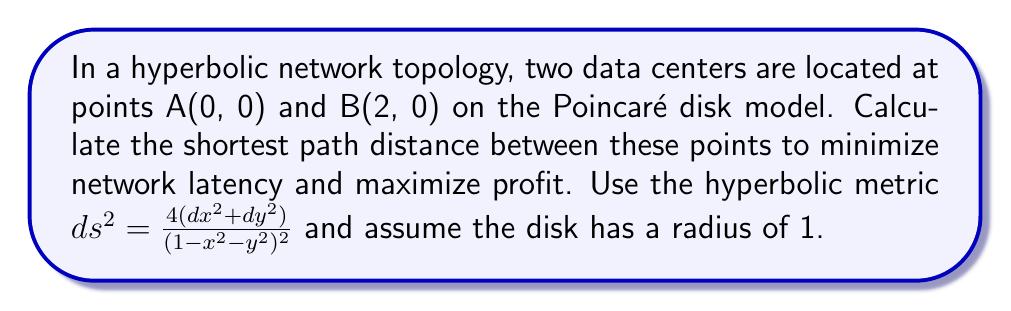Teach me how to tackle this problem. 1. In the Poincaré disk model, the shortest path between two points is along a geodesic, which is represented by either a circular arc perpendicular to the boundary circle or a straight line through the center.

2. Since both points lie on the x-axis, the geodesic is a straight line segment.

3. The hyperbolic distance formula for two points $(x_1, y_1)$ and $(x_2, y_2)$ on the same diameter of the Poincaré disk is:

   $$d = 2 \tanh^{-1}\left(\frac{|x_2 - x_1|}{2-|x_2 - x_1|}\right)$$

4. Substitute the given coordinates:
   $x_1 = 0$, $y_1 = 0$, $x_2 = 2$, $y_2 = 0$

   $$d = 2 \tanh^{-1}\left(\frac{|2 - 0|}{2-|2 - 0|}\right) = 2 \tanh^{-1}\left(\frac{2}{0}\right)$$

5. Since $\tanh^{-1}(x)$ is undefined for $x \geq 1$, we need to approach this limit:

   $$\lim_{x \to 1^-} 2 \tanh^{-1}(x) = \infty$$

6. This result indicates that the hyperbolic distance between the two points is infinite, despite their finite Euclidean distance.
Answer: The shortest path distance is infinite. 